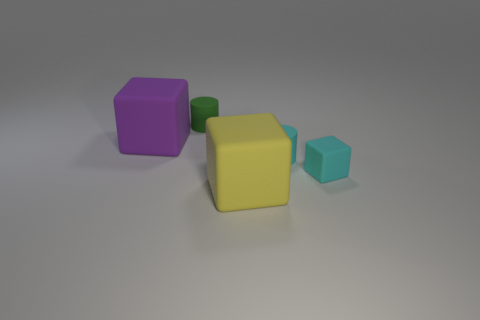Add 3 purple cubes. How many objects exist? 8 Subtract all cubes. How many objects are left? 2 Subtract all large cubes. Subtract all yellow metal cylinders. How many objects are left? 3 Add 5 large yellow rubber cubes. How many large yellow rubber cubes are left? 6 Add 2 big rubber objects. How many big rubber objects exist? 4 Subtract 1 green cylinders. How many objects are left? 4 